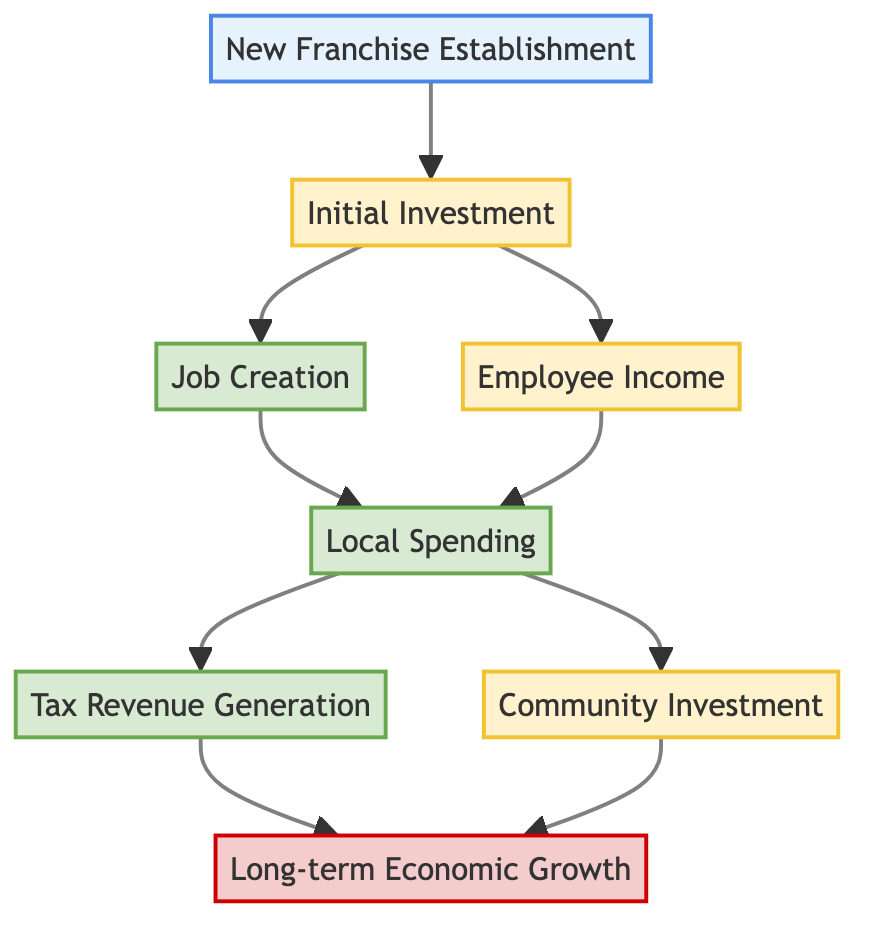What is the input of the diagram? The input is "New Franchise Establishment," which represents the introduction of a successful franchise to the local market.
Answer: New Franchise Establishment How many output nodes are in the diagram? There are three output nodes: "Job Creation," "Local Spending," and "Tax Revenue Generation."
Answer: Three What process immediately follows "Initial Investment"? The process that immediately follows "Initial Investment" is "Job Creation."
Answer: Job Creation What are the outputs from the "Local Spending" node? "Local Spending" leads to two outputs: "Tax Revenue Generation" and "Community Investment."
Answer: Tax Revenue Generation and Community Investment Which node is the final outcome of this flowchart? The final outcome of the flowchart is "Long-term Economic Growth."
Answer: Long-term Economic Growth What type of nodes are "Employee Income" and "Community Investment"? Both "Employee Income" and "Community Investment" are classified as process nodes.
Answer: Process Which output node is directly affected by "Job Creation"? The output node directly affected by "Job Creation" is "Local Spending."
Answer: Local Spending How does "Community Investment" contribute to the economic impact analysis? "Community Investment" enhances community ties, which is part of the processes leading to the final outcome.
Answer: Enhances community ties What leads to "Long-term Economic Growth"? "Long-term Economic Growth" is led by both "Tax Revenue Generation" and "Community Investment."
Answer: Tax Revenue Generation and Community Investment 